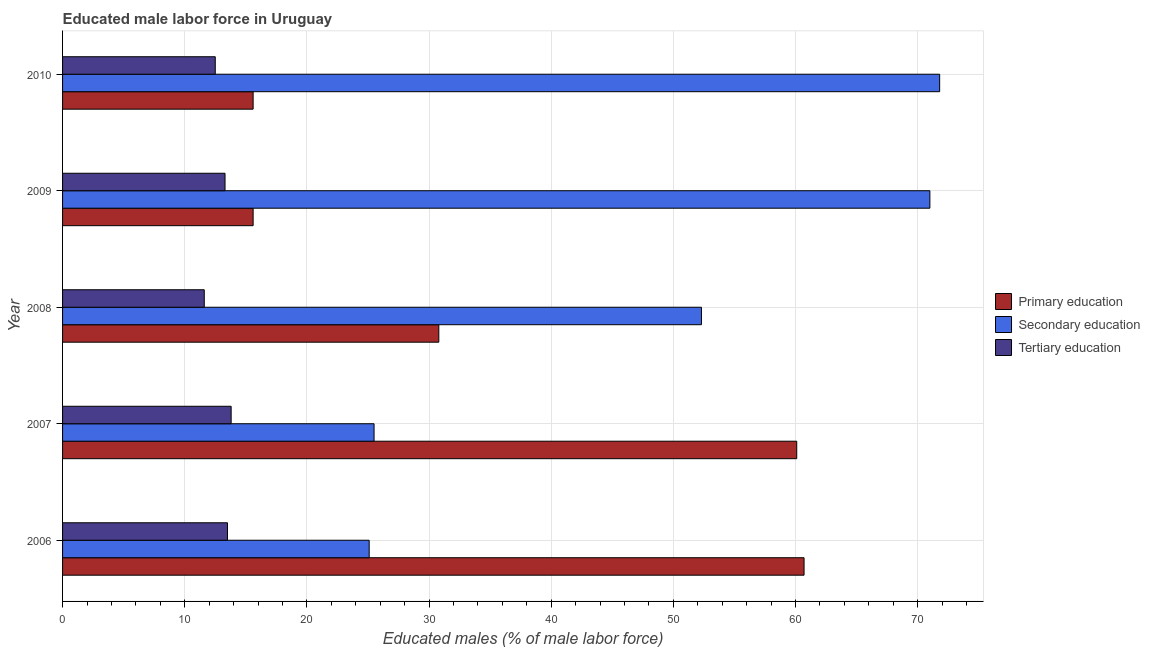How many different coloured bars are there?
Keep it short and to the point. 3. How many groups of bars are there?
Give a very brief answer. 5. Are the number of bars per tick equal to the number of legend labels?
Make the answer very short. Yes. Are the number of bars on each tick of the Y-axis equal?
Give a very brief answer. Yes. Across all years, what is the maximum percentage of male labor force who received primary education?
Your answer should be very brief. 60.7. Across all years, what is the minimum percentage of male labor force who received tertiary education?
Your answer should be compact. 11.6. What is the total percentage of male labor force who received secondary education in the graph?
Ensure brevity in your answer.  245.7. What is the difference between the percentage of male labor force who received primary education in 2006 and the percentage of male labor force who received tertiary education in 2007?
Ensure brevity in your answer.  46.9. What is the average percentage of male labor force who received primary education per year?
Offer a terse response. 36.56. In the year 2006, what is the difference between the percentage of male labor force who received tertiary education and percentage of male labor force who received primary education?
Your response must be concise. -47.2. In how many years, is the percentage of male labor force who received secondary education greater than 18 %?
Ensure brevity in your answer.  5. What is the difference between the highest and the lowest percentage of male labor force who received primary education?
Your response must be concise. 45.1. In how many years, is the percentage of male labor force who received secondary education greater than the average percentage of male labor force who received secondary education taken over all years?
Your answer should be very brief. 3. Is the sum of the percentage of male labor force who received primary education in 2007 and 2009 greater than the maximum percentage of male labor force who received secondary education across all years?
Offer a very short reply. Yes. What does the 1st bar from the top in 2008 represents?
Keep it short and to the point. Tertiary education. What does the 3rd bar from the bottom in 2008 represents?
Offer a terse response. Tertiary education. Is it the case that in every year, the sum of the percentage of male labor force who received primary education and percentage of male labor force who received secondary education is greater than the percentage of male labor force who received tertiary education?
Provide a succinct answer. Yes. Are all the bars in the graph horizontal?
Offer a very short reply. Yes. Are the values on the major ticks of X-axis written in scientific E-notation?
Make the answer very short. No. Does the graph contain grids?
Offer a very short reply. Yes. Where does the legend appear in the graph?
Offer a very short reply. Center right. How many legend labels are there?
Your answer should be compact. 3. How are the legend labels stacked?
Your answer should be compact. Vertical. What is the title of the graph?
Ensure brevity in your answer.  Educated male labor force in Uruguay. What is the label or title of the X-axis?
Offer a very short reply. Educated males (% of male labor force). What is the Educated males (% of male labor force) of Primary education in 2006?
Your answer should be compact. 60.7. What is the Educated males (% of male labor force) of Secondary education in 2006?
Your response must be concise. 25.1. What is the Educated males (% of male labor force) of Primary education in 2007?
Offer a terse response. 60.1. What is the Educated males (% of male labor force) in Secondary education in 2007?
Offer a very short reply. 25.5. What is the Educated males (% of male labor force) of Tertiary education in 2007?
Make the answer very short. 13.8. What is the Educated males (% of male labor force) of Primary education in 2008?
Give a very brief answer. 30.8. What is the Educated males (% of male labor force) of Secondary education in 2008?
Your answer should be very brief. 52.3. What is the Educated males (% of male labor force) of Tertiary education in 2008?
Provide a short and direct response. 11.6. What is the Educated males (% of male labor force) in Primary education in 2009?
Give a very brief answer. 15.6. What is the Educated males (% of male labor force) in Tertiary education in 2009?
Provide a short and direct response. 13.3. What is the Educated males (% of male labor force) of Primary education in 2010?
Your response must be concise. 15.6. What is the Educated males (% of male labor force) in Secondary education in 2010?
Keep it short and to the point. 71.8. Across all years, what is the maximum Educated males (% of male labor force) of Primary education?
Provide a short and direct response. 60.7. Across all years, what is the maximum Educated males (% of male labor force) in Secondary education?
Keep it short and to the point. 71.8. Across all years, what is the maximum Educated males (% of male labor force) in Tertiary education?
Keep it short and to the point. 13.8. Across all years, what is the minimum Educated males (% of male labor force) of Primary education?
Ensure brevity in your answer.  15.6. Across all years, what is the minimum Educated males (% of male labor force) of Secondary education?
Give a very brief answer. 25.1. Across all years, what is the minimum Educated males (% of male labor force) in Tertiary education?
Offer a terse response. 11.6. What is the total Educated males (% of male labor force) of Primary education in the graph?
Provide a short and direct response. 182.8. What is the total Educated males (% of male labor force) in Secondary education in the graph?
Your answer should be compact. 245.7. What is the total Educated males (% of male labor force) of Tertiary education in the graph?
Offer a terse response. 64.7. What is the difference between the Educated males (% of male labor force) in Primary education in 2006 and that in 2007?
Your answer should be very brief. 0.6. What is the difference between the Educated males (% of male labor force) of Secondary education in 2006 and that in 2007?
Ensure brevity in your answer.  -0.4. What is the difference between the Educated males (% of male labor force) in Tertiary education in 2006 and that in 2007?
Your answer should be compact. -0.3. What is the difference between the Educated males (% of male labor force) of Primary education in 2006 and that in 2008?
Your answer should be very brief. 29.9. What is the difference between the Educated males (% of male labor force) of Secondary education in 2006 and that in 2008?
Make the answer very short. -27.2. What is the difference between the Educated males (% of male labor force) of Primary education in 2006 and that in 2009?
Your answer should be very brief. 45.1. What is the difference between the Educated males (% of male labor force) of Secondary education in 2006 and that in 2009?
Give a very brief answer. -45.9. What is the difference between the Educated males (% of male labor force) in Tertiary education in 2006 and that in 2009?
Your answer should be very brief. 0.2. What is the difference between the Educated males (% of male labor force) of Primary education in 2006 and that in 2010?
Your response must be concise. 45.1. What is the difference between the Educated males (% of male labor force) of Secondary education in 2006 and that in 2010?
Provide a succinct answer. -46.7. What is the difference between the Educated males (% of male labor force) of Primary education in 2007 and that in 2008?
Give a very brief answer. 29.3. What is the difference between the Educated males (% of male labor force) of Secondary education in 2007 and that in 2008?
Offer a terse response. -26.8. What is the difference between the Educated males (% of male labor force) in Tertiary education in 2007 and that in 2008?
Your response must be concise. 2.2. What is the difference between the Educated males (% of male labor force) in Primary education in 2007 and that in 2009?
Your answer should be very brief. 44.5. What is the difference between the Educated males (% of male labor force) of Secondary education in 2007 and that in 2009?
Provide a succinct answer. -45.5. What is the difference between the Educated males (% of male labor force) in Tertiary education in 2007 and that in 2009?
Provide a succinct answer. 0.5. What is the difference between the Educated males (% of male labor force) in Primary education in 2007 and that in 2010?
Your response must be concise. 44.5. What is the difference between the Educated males (% of male labor force) in Secondary education in 2007 and that in 2010?
Provide a short and direct response. -46.3. What is the difference between the Educated males (% of male labor force) of Secondary education in 2008 and that in 2009?
Give a very brief answer. -18.7. What is the difference between the Educated males (% of male labor force) of Primary education in 2008 and that in 2010?
Provide a short and direct response. 15.2. What is the difference between the Educated males (% of male labor force) in Secondary education in 2008 and that in 2010?
Ensure brevity in your answer.  -19.5. What is the difference between the Educated males (% of male labor force) in Tertiary education in 2008 and that in 2010?
Your answer should be very brief. -0.9. What is the difference between the Educated males (% of male labor force) in Secondary education in 2009 and that in 2010?
Offer a terse response. -0.8. What is the difference between the Educated males (% of male labor force) of Tertiary education in 2009 and that in 2010?
Your answer should be compact. 0.8. What is the difference between the Educated males (% of male labor force) of Primary education in 2006 and the Educated males (% of male labor force) of Secondary education in 2007?
Offer a terse response. 35.2. What is the difference between the Educated males (% of male labor force) of Primary education in 2006 and the Educated males (% of male labor force) of Tertiary education in 2007?
Provide a succinct answer. 46.9. What is the difference between the Educated males (% of male labor force) in Primary education in 2006 and the Educated males (% of male labor force) in Secondary education in 2008?
Give a very brief answer. 8.4. What is the difference between the Educated males (% of male labor force) of Primary education in 2006 and the Educated males (% of male labor force) of Tertiary education in 2008?
Provide a short and direct response. 49.1. What is the difference between the Educated males (% of male labor force) of Primary education in 2006 and the Educated males (% of male labor force) of Tertiary education in 2009?
Your answer should be compact. 47.4. What is the difference between the Educated males (% of male labor force) in Secondary education in 2006 and the Educated males (% of male labor force) in Tertiary education in 2009?
Keep it short and to the point. 11.8. What is the difference between the Educated males (% of male labor force) of Primary education in 2006 and the Educated males (% of male labor force) of Secondary education in 2010?
Your answer should be very brief. -11.1. What is the difference between the Educated males (% of male labor force) of Primary education in 2006 and the Educated males (% of male labor force) of Tertiary education in 2010?
Provide a short and direct response. 48.2. What is the difference between the Educated males (% of male labor force) in Primary education in 2007 and the Educated males (% of male labor force) in Secondary education in 2008?
Provide a succinct answer. 7.8. What is the difference between the Educated males (% of male labor force) of Primary education in 2007 and the Educated males (% of male labor force) of Tertiary education in 2008?
Your answer should be compact. 48.5. What is the difference between the Educated males (% of male labor force) of Secondary education in 2007 and the Educated males (% of male labor force) of Tertiary education in 2008?
Your answer should be very brief. 13.9. What is the difference between the Educated males (% of male labor force) of Primary education in 2007 and the Educated males (% of male labor force) of Secondary education in 2009?
Keep it short and to the point. -10.9. What is the difference between the Educated males (% of male labor force) of Primary education in 2007 and the Educated males (% of male labor force) of Tertiary education in 2009?
Your answer should be compact. 46.8. What is the difference between the Educated males (% of male labor force) of Secondary education in 2007 and the Educated males (% of male labor force) of Tertiary education in 2009?
Keep it short and to the point. 12.2. What is the difference between the Educated males (% of male labor force) of Primary education in 2007 and the Educated males (% of male labor force) of Tertiary education in 2010?
Provide a succinct answer. 47.6. What is the difference between the Educated males (% of male labor force) of Secondary education in 2007 and the Educated males (% of male labor force) of Tertiary education in 2010?
Give a very brief answer. 13. What is the difference between the Educated males (% of male labor force) in Primary education in 2008 and the Educated males (% of male labor force) in Secondary education in 2009?
Ensure brevity in your answer.  -40.2. What is the difference between the Educated males (% of male labor force) of Primary education in 2008 and the Educated males (% of male labor force) of Tertiary education in 2009?
Offer a terse response. 17.5. What is the difference between the Educated males (% of male labor force) in Secondary education in 2008 and the Educated males (% of male labor force) in Tertiary education in 2009?
Offer a very short reply. 39. What is the difference between the Educated males (% of male labor force) in Primary education in 2008 and the Educated males (% of male labor force) in Secondary education in 2010?
Offer a terse response. -41. What is the difference between the Educated males (% of male labor force) of Secondary education in 2008 and the Educated males (% of male labor force) of Tertiary education in 2010?
Give a very brief answer. 39.8. What is the difference between the Educated males (% of male labor force) of Primary education in 2009 and the Educated males (% of male labor force) of Secondary education in 2010?
Offer a terse response. -56.2. What is the difference between the Educated males (% of male labor force) in Secondary education in 2009 and the Educated males (% of male labor force) in Tertiary education in 2010?
Offer a terse response. 58.5. What is the average Educated males (% of male labor force) of Primary education per year?
Provide a succinct answer. 36.56. What is the average Educated males (% of male labor force) in Secondary education per year?
Ensure brevity in your answer.  49.14. What is the average Educated males (% of male labor force) in Tertiary education per year?
Make the answer very short. 12.94. In the year 2006, what is the difference between the Educated males (% of male labor force) in Primary education and Educated males (% of male labor force) in Secondary education?
Give a very brief answer. 35.6. In the year 2006, what is the difference between the Educated males (% of male labor force) in Primary education and Educated males (% of male labor force) in Tertiary education?
Make the answer very short. 47.2. In the year 2006, what is the difference between the Educated males (% of male labor force) in Secondary education and Educated males (% of male labor force) in Tertiary education?
Keep it short and to the point. 11.6. In the year 2007, what is the difference between the Educated males (% of male labor force) in Primary education and Educated males (% of male labor force) in Secondary education?
Your response must be concise. 34.6. In the year 2007, what is the difference between the Educated males (% of male labor force) of Primary education and Educated males (% of male labor force) of Tertiary education?
Offer a very short reply. 46.3. In the year 2007, what is the difference between the Educated males (% of male labor force) of Secondary education and Educated males (% of male labor force) of Tertiary education?
Give a very brief answer. 11.7. In the year 2008, what is the difference between the Educated males (% of male labor force) of Primary education and Educated males (% of male labor force) of Secondary education?
Offer a terse response. -21.5. In the year 2008, what is the difference between the Educated males (% of male labor force) in Primary education and Educated males (% of male labor force) in Tertiary education?
Ensure brevity in your answer.  19.2. In the year 2008, what is the difference between the Educated males (% of male labor force) in Secondary education and Educated males (% of male labor force) in Tertiary education?
Offer a very short reply. 40.7. In the year 2009, what is the difference between the Educated males (% of male labor force) in Primary education and Educated males (% of male labor force) in Secondary education?
Provide a short and direct response. -55.4. In the year 2009, what is the difference between the Educated males (% of male labor force) of Secondary education and Educated males (% of male labor force) of Tertiary education?
Offer a very short reply. 57.7. In the year 2010, what is the difference between the Educated males (% of male labor force) of Primary education and Educated males (% of male labor force) of Secondary education?
Offer a very short reply. -56.2. In the year 2010, what is the difference between the Educated males (% of male labor force) in Primary education and Educated males (% of male labor force) in Tertiary education?
Give a very brief answer. 3.1. In the year 2010, what is the difference between the Educated males (% of male labor force) of Secondary education and Educated males (% of male labor force) of Tertiary education?
Offer a very short reply. 59.3. What is the ratio of the Educated males (% of male labor force) in Secondary education in 2006 to that in 2007?
Offer a terse response. 0.98. What is the ratio of the Educated males (% of male labor force) of Tertiary education in 2006 to that in 2007?
Your answer should be compact. 0.98. What is the ratio of the Educated males (% of male labor force) of Primary education in 2006 to that in 2008?
Offer a very short reply. 1.97. What is the ratio of the Educated males (% of male labor force) in Secondary education in 2006 to that in 2008?
Make the answer very short. 0.48. What is the ratio of the Educated males (% of male labor force) in Tertiary education in 2006 to that in 2008?
Your answer should be compact. 1.16. What is the ratio of the Educated males (% of male labor force) in Primary education in 2006 to that in 2009?
Ensure brevity in your answer.  3.89. What is the ratio of the Educated males (% of male labor force) in Secondary education in 2006 to that in 2009?
Make the answer very short. 0.35. What is the ratio of the Educated males (% of male labor force) in Primary education in 2006 to that in 2010?
Your answer should be very brief. 3.89. What is the ratio of the Educated males (% of male labor force) in Secondary education in 2006 to that in 2010?
Ensure brevity in your answer.  0.35. What is the ratio of the Educated males (% of male labor force) of Tertiary education in 2006 to that in 2010?
Provide a short and direct response. 1.08. What is the ratio of the Educated males (% of male labor force) of Primary education in 2007 to that in 2008?
Your response must be concise. 1.95. What is the ratio of the Educated males (% of male labor force) in Secondary education in 2007 to that in 2008?
Your answer should be compact. 0.49. What is the ratio of the Educated males (% of male labor force) in Tertiary education in 2007 to that in 2008?
Give a very brief answer. 1.19. What is the ratio of the Educated males (% of male labor force) in Primary education in 2007 to that in 2009?
Your answer should be compact. 3.85. What is the ratio of the Educated males (% of male labor force) in Secondary education in 2007 to that in 2009?
Offer a terse response. 0.36. What is the ratio of the Educated males (% of male labor force) in Tertiary education in 2007 to that in 2009?
Give a very brief answer. 1.04. What is the ratio of the Educated males (% of male labor force) of Primary education in 2007 to that in 2010?
Your answer should be very brief. 3.85. What is the ratio of the Educated males (% of male labor force) in Secondary education in 2007 to that in 2010?
Your answer should be very brief. 0.36. What is the ratio of the Educated males (% of male labor force) of Tertiary education in 2007 to that in 2010?
Provide a short and direct response. 1.1. What is the ratio of the Educated males (% of male labor force) in Primary education in 2008 to that in 2009?
Your answer should be compact. 1.97. What is the ratio of the Educated males (% of male labor force) of Secondary education in 2008 to that in 2009?
Your answer should be very brief. 0.74. What is the ratio of the Educated males (% of male labor force) in Tertiary education in 2008 to that in 2009?
Your response must be concise. 0.87. What is the ratio of the Educated males (% of male labor force) in Primary education in 2008 to that in 2010?
Offer a very short reply. 1.97. What is the ratio of the Educated males (% of male labor force) of Secondary education in 2008 to that in 2010?
Give a very brief answer. 0.73. What is the ratio of the Educated males (% of male labor force) in Tertiary education in 2008 to that in 2010?
Keep it short and to the point. 0.93. What is the ratio of the Educated males (% of male labor force) in Secondary education in 2009 to that in 2010?
Offer a very short reply. 0.99. What is the ratio of the Educated males (% of male labor force) of Tertiary education in 2009 to that in 2010?
Offer a very short reply. 1.06. What is the difference between the highest and the second highest Educated males (% of male labor force) in Primary education?
Offer a terse response. 0.6. What is the difference between the highest and the second highest Educated males (% of male labor force) in Secondary education?
Offer a very short reply. 0.8. What is the difference between the highest and the lowest Educated males (% of male labor force) in Primary education?
Offer a very short reply. 45.1. What is the difference between the highest and the lowest Educated males (% of male labor force) in Secondary education?
Offer a very short reply. 46.7. What is the difference between the highest and the lowest Educated males (% of male labor force) in Tertiary education?
Make the answer very short. 2.2. 